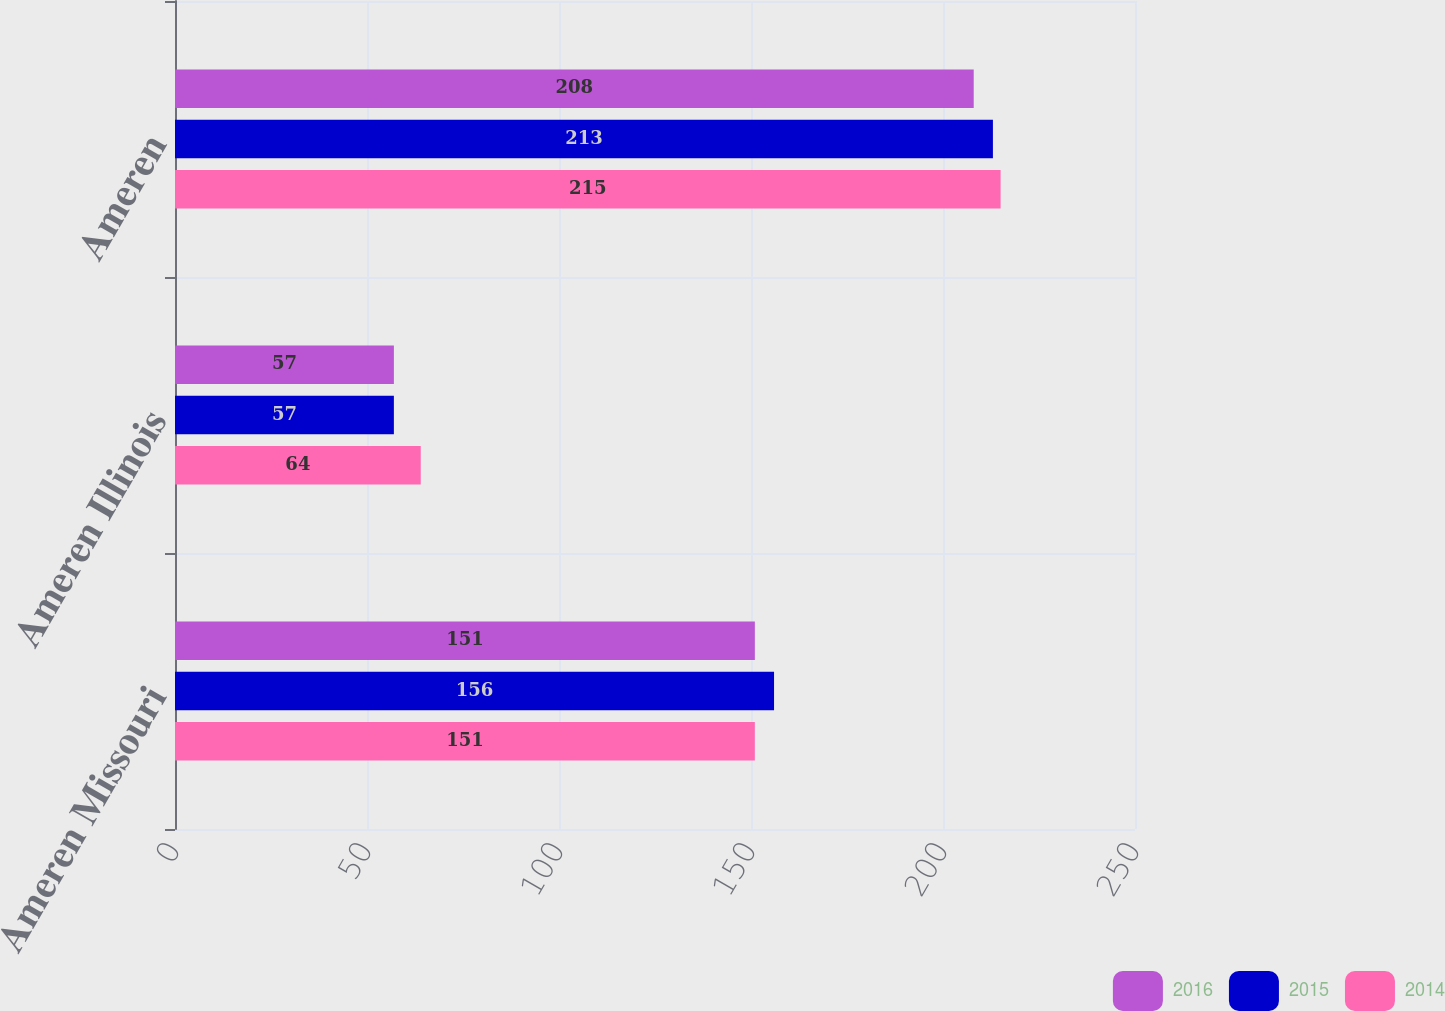Convert chart to OTSL. <chart><loc_0><loc_0><loc_500><loc_500><stacked_bar_chart><ecel><fcel>Ameren Missouri<fcel>Ameren Illinois<fcel>Ameren<nl><fcel>2016<fcel>151<fcel>57<fcel>208<nl><fcel>2015<fcel>156<fcel>57<fcel>213<nl><fcel>2014<fcel>151<fcel>64<fcel>215<nl></chart> 